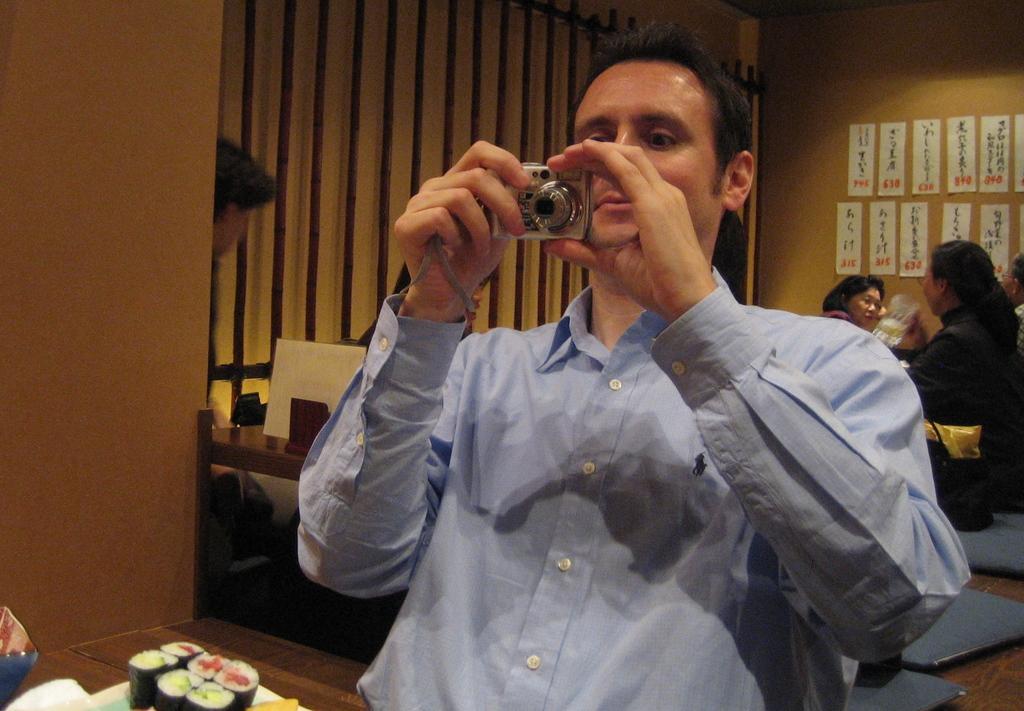Please provide a concise description of this image. In this picture, there is a man sitting he is holding a camera with both of his hand, and is looking into the camera and there is a table in front of him with some food served in the plate in the backdrop there are a group of people sitting and there is a wall with some pictures pasted on it 